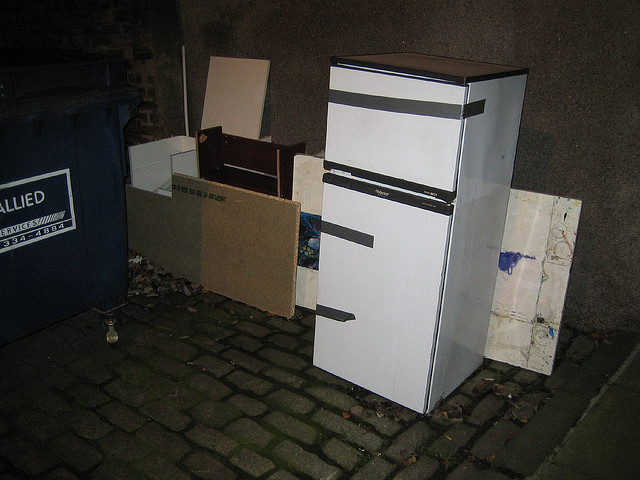Identify and read out the text in this image. ALLIED SERVICER 3 3 A 4884 